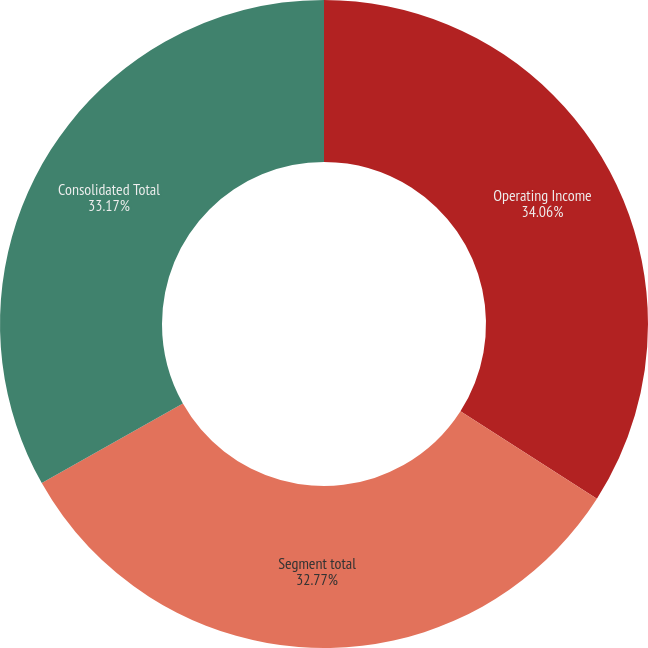<chart> <loc_0><loc_0><loc_500><loc_500><pie_chart><fcel>Operating Income<fcel>Segment total<fcel>Consolidated Total<nl><fcel>34.06%<fcel>32.77%<fcel>33.17%<nl></chart> 